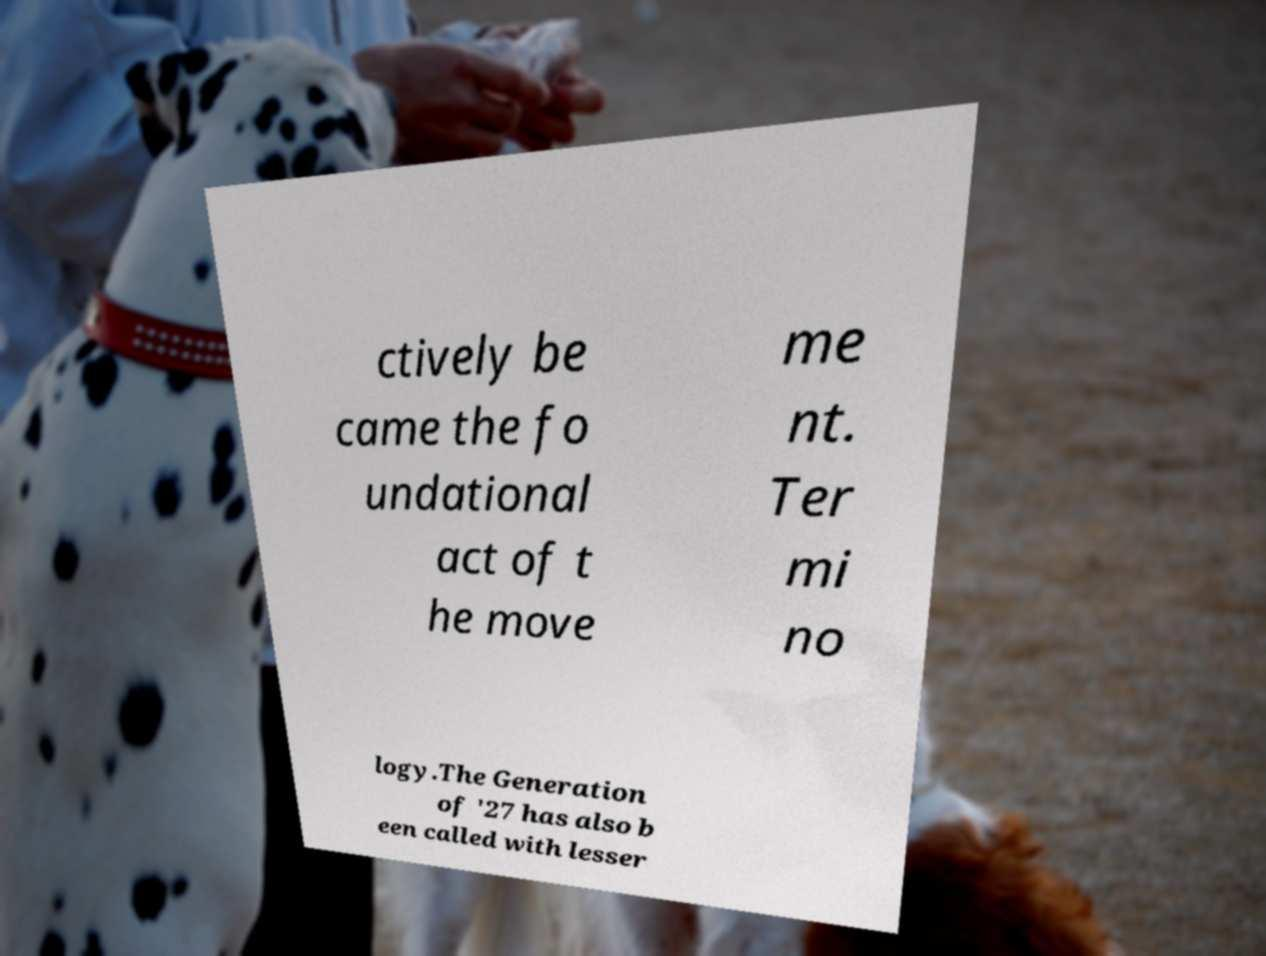Please read and relay the text visible in this image. What does it say? ctively be came the fo undational act of t he move me nt. Ter mi no logy.The Generation of '27 has also b een called with lesser 